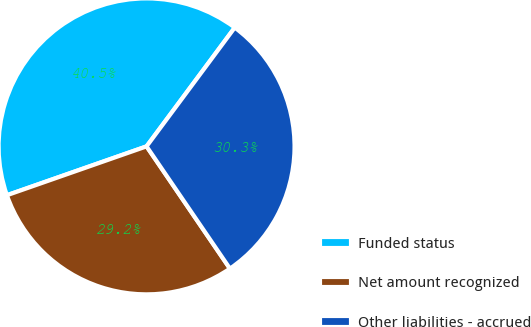<chart> <loc_0><loc_0><loc_500><loc_500><pie_chart><fcel>Funded status<fcel>Net amount recognized<fcel>Other liabilities - accrued<nl><fcel>40.52%<fcel>29.17%<fcel>30.31%<nl></chart> 